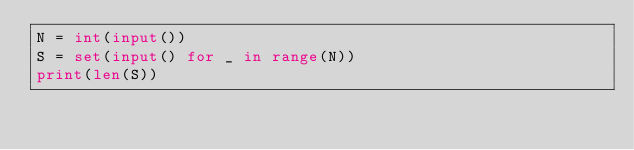<code> <loc_0><loc_0><loc_500><loc_500><_Python_>N = int(input())
S = set(input() for _ in range(N))
print(len(S))
</code> 